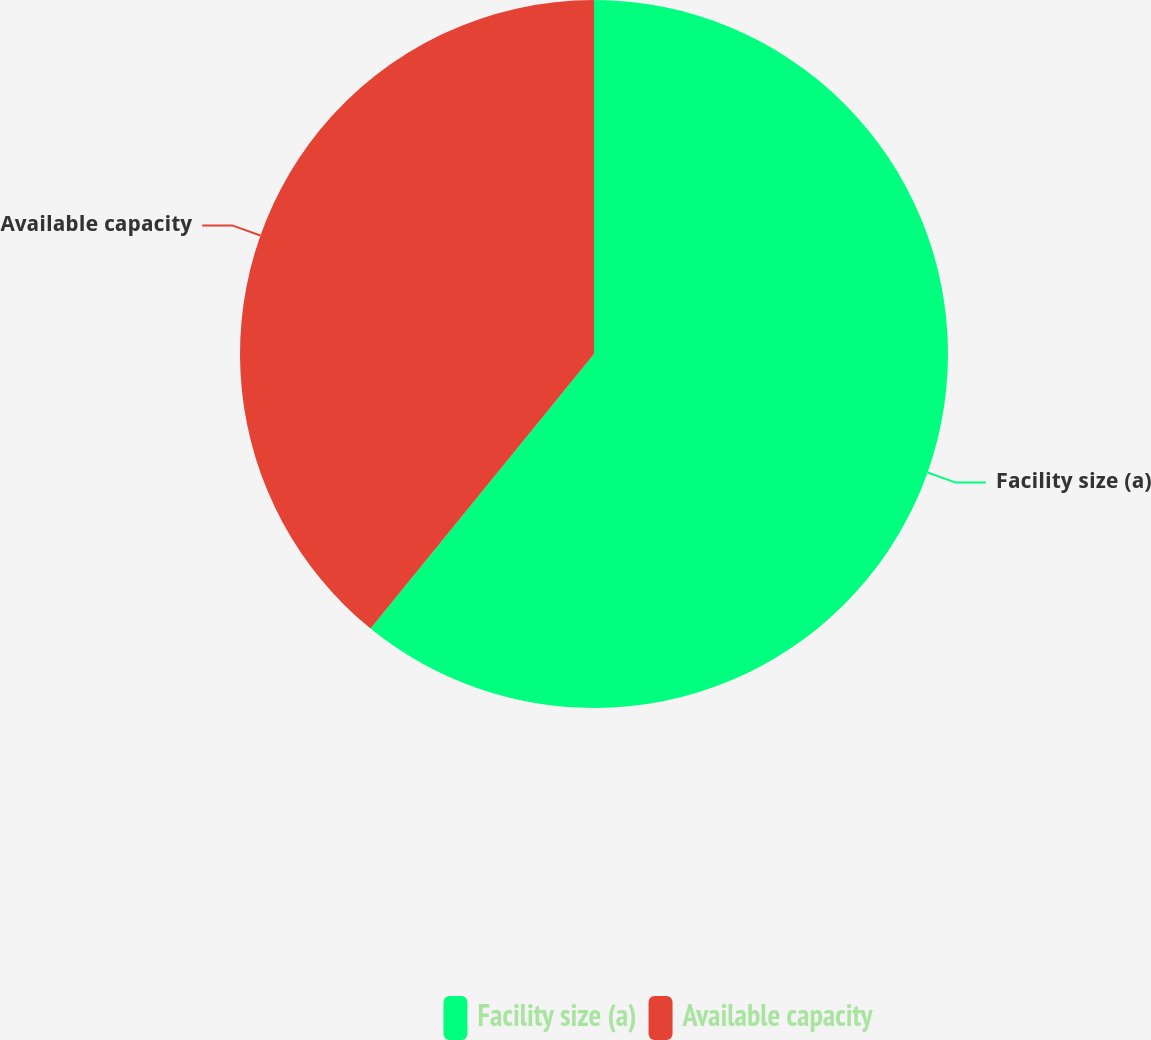Convert chart to OTSL. <chart><loc_0><loc_0><loc_500><loc_500><pie_chart><fcel>Facility size (a)<fcel>Available capacity<nl><fcel>60.87%<fcel>39.13%<nl></chart> 